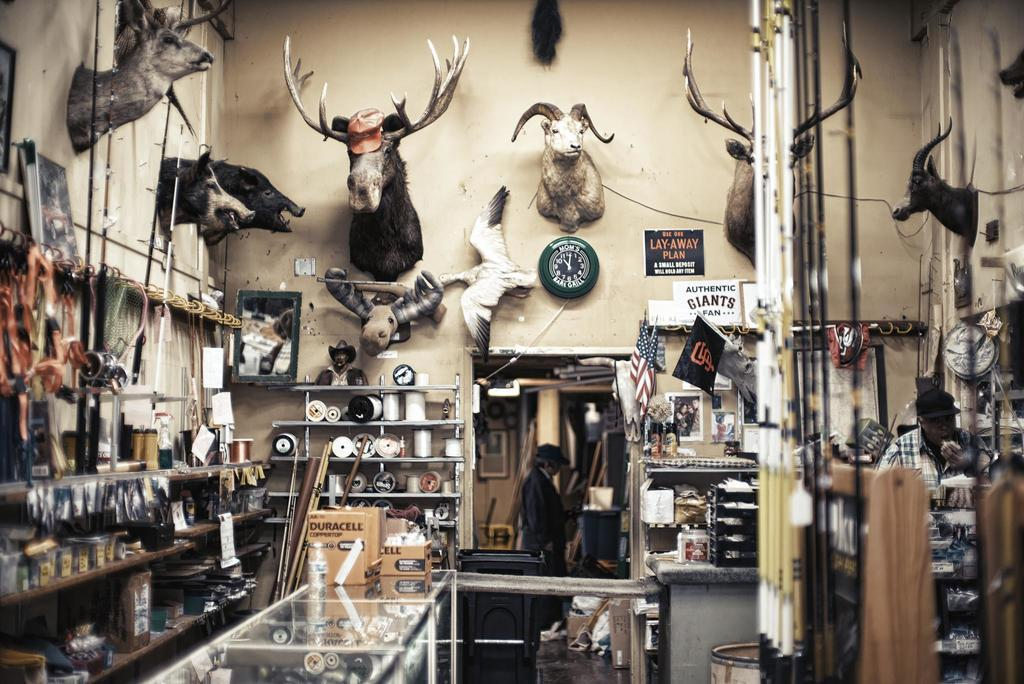<image>
Create a compact narrative representing the image presented. Sporting goods area that has a clock on the wall that has Mom's Bar & Grill on it. 